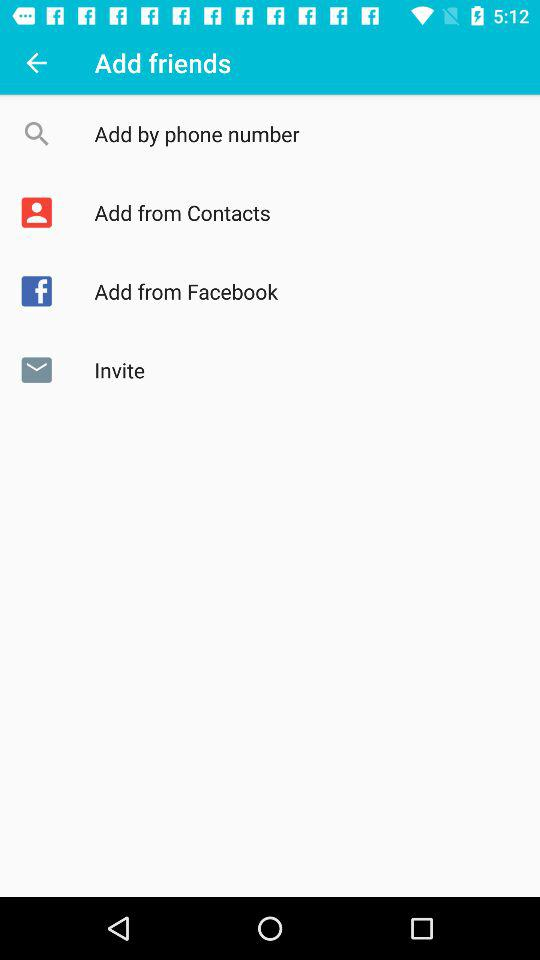How many ways can you add friends?
Answer the question using a single word or phrase. 4 